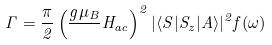Convert formula to latex. <formula><loc_0><loc_0><loc_500><loc_500>\Gamma = { \frac { \pi } { 2 } } \left ( { \frac { g \mu _ { B } } { } } H _ { a c } \right ) ^ { 2 } | \langle S | S _ { z } | A \rangle | ^ { 2 } f ( \omega ) \,</formula> 